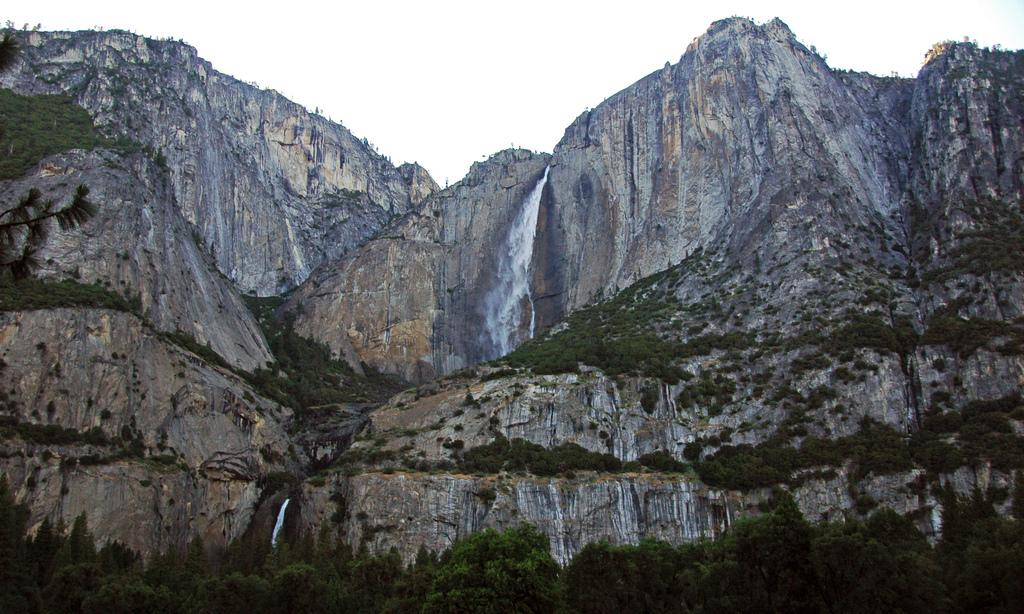What geographical feature is the main subject of the image? There is a mountain in the image. What is a notable feature of the mountain? There is a waterfall on the mountain. What type of vegetation can be seen in the image? There are group of trees and plants in the image. What is visible at the top of the image? The sky is visible at the top of the image. Can you see any snakes slithering near the waterfall in the image? There are no snakes visible in the image. Is there any smoke coming from the mountain in the image? There is no smoke present in the image. 